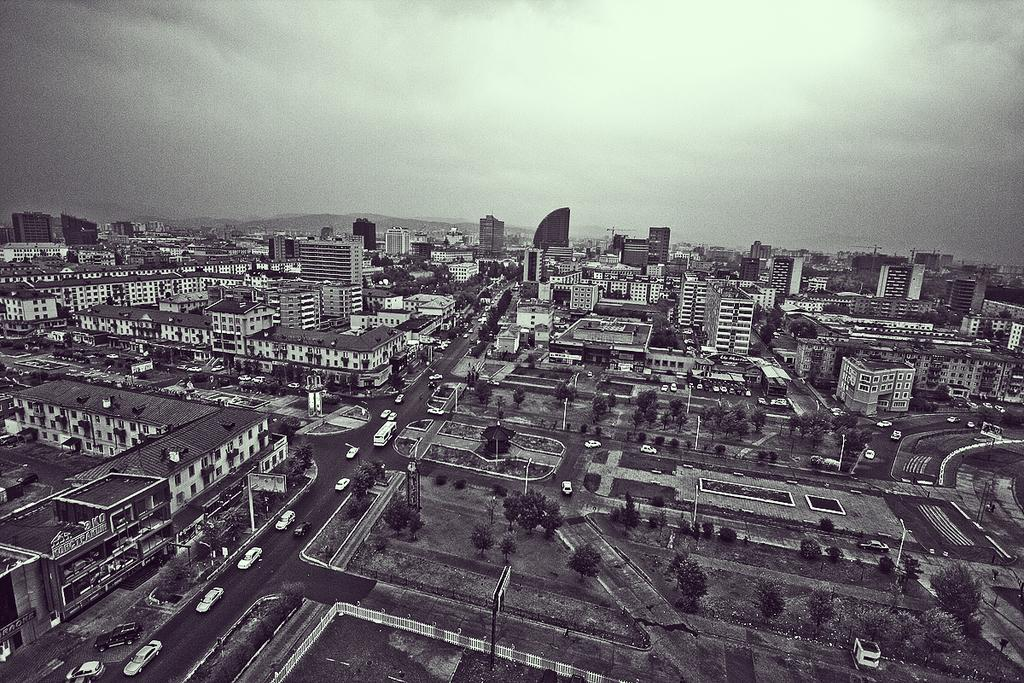What type of structures can be seen in the image? There are buildings in the image. What type of transportation infrastructure is present in the image? There are roads and vehicles visible in the image. What type of natural elements can be seen in the image? There are trees and mountains in the image. What type of man-made objects can be seen in the image? There are poles in the image. What type of living organisms can be seen in the image? There are people in the image. What is visible at the top of the image? The sky is visible at the top of the image. Can you tell me how many icicles are hanging from the buildings in the image? There are no icicles present in the image; it appears to be a clear day with no ice formations. What type of pen is being used by the people in the image? There is no pen visible in the image, and it is not possible to determine what type of pen the people might be using. 